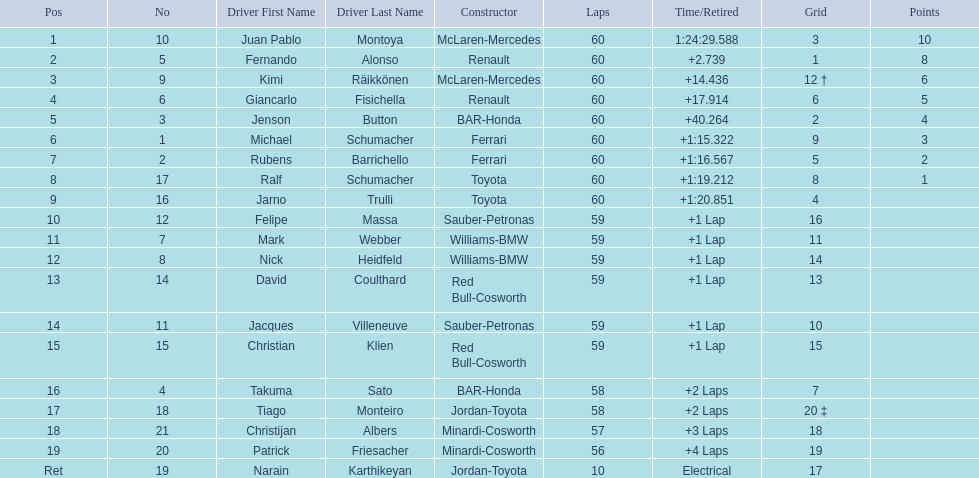How many drivers from germany? 3. 